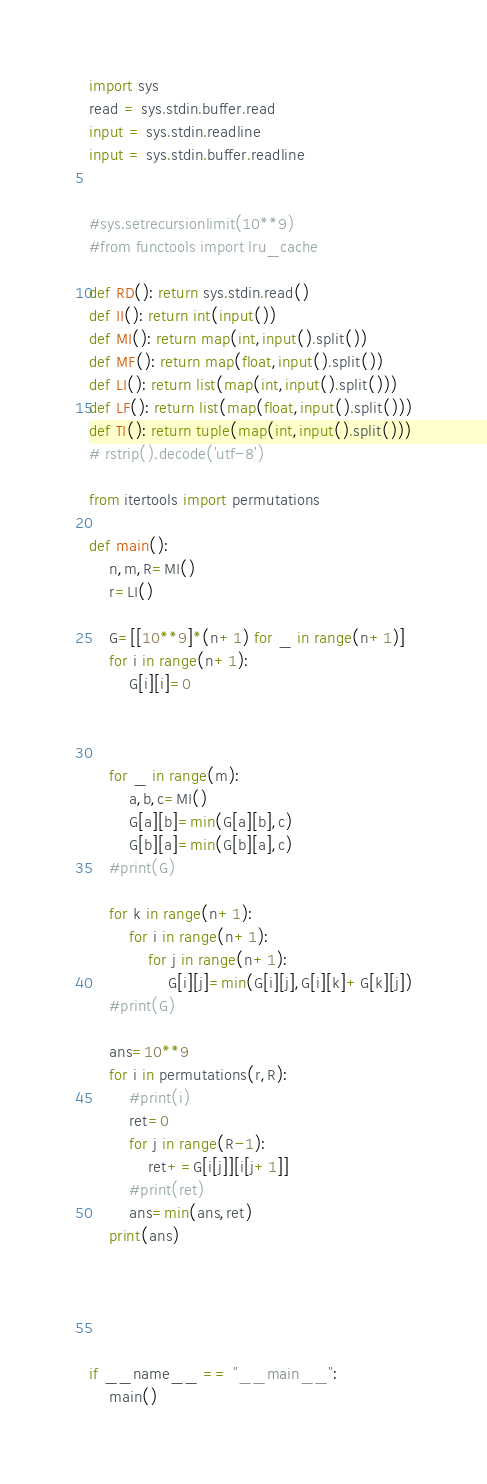Convert code to text. <code><loc_0><loc_0><loc_500><loc_500><_Python_>import sys
read = sys.stdin.buffer.read
input = sys.stdin.readline
input = sys.stdin.buffer.readline


#sys.setrecursionlimit(10**9)
#from functools import lru_cache

def RD(): return sys.stdin.read()
def II(): return int(input())
def MI(): return map(int,input().split())
def MF(): return map(float,input().split())
def LI(): return list(map(int,input().split()))
def LF(): return list(map(float,input().split()))
def TI(): return tuple(map(int,input().split()))
# rstrip().decode('utf-8')

from itertools import permutations

def main():
	n,m,R=MI()
	r=LI()

	G=[[10**9]*(n+1) for _ in range(n+1)]
	for i in range(n+1):
		G[i][i]=0



	for _ in range(m):
		a,b,c=MI()
		G[a][b]=min(G[a][b],c)
		G[b][a]=min(G[b][a],c)
	#print(G)

	for k in range(n+1):
		for i in range(n+1):
			for j in range(n+1):
				G[i][j]=min(G[i][j],G[i][k]+G[k][j])
	#print(G)

	ans=10**9
	for i in permutations(r,R):
		#print(i)
		ret=0
		for j in range(R-1):
			ret+=G[i[j]][i[j+1]]
		#print(ret)
		ans=min(ans,ret)
	print(ans)





if __name__ == "__main__":
	main()
</code> 